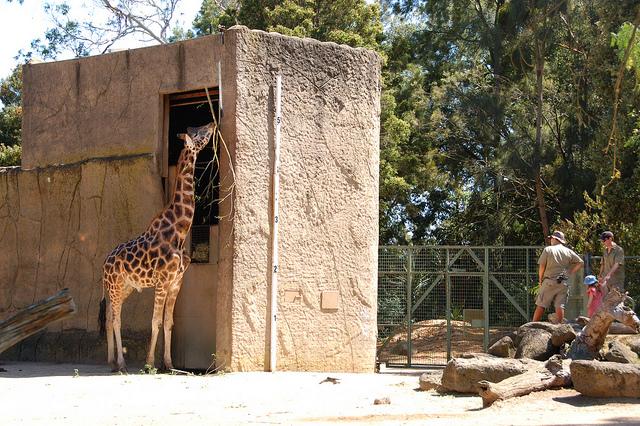What are the giraffes trying to reach?
Write a very short answer. Branch. Is the giraffe in it's natural habitat?
Be succinct. No. What side of the wall is the animal on?
Concise answer only. Left. How many people are in the picture?
Give a very brief answer. 3. 